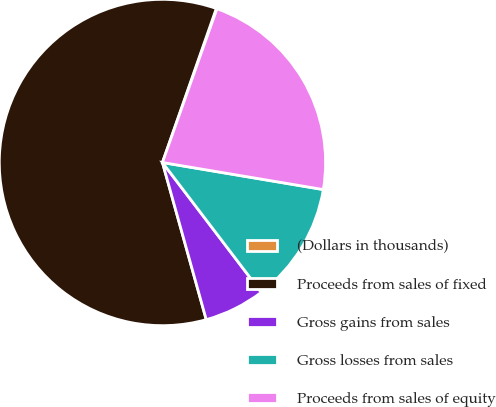<chart> <loc_0><loc_0><loc_500><loc_500><pie_chart><fcel>(Dollars in thousands)<fcel>Proceeds from sales of fixed<fcel>Gross gains from sales<fcel>Gross losses from sales<fcel>Proceeds from sales of equity<nl><fcel>0.07%<fcel>59.68%<fcel>6.03%<fcel>11.99%<fcel>22.23%<nl></chart> 